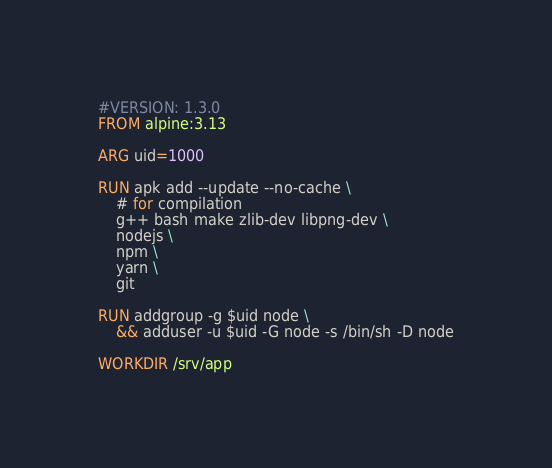Convert code to text. <code><loc_0><loc_0><loc_500><loc_500><_Dockerfile_>#VERSION: 1.3.0
FROM alpine:3.13

ARG uid=1000

RUN apk add --update --no-cache \
    # for compilation
    g++ bash make zlib-dev libpng-dev \
	nodejs \
	npm \
	yarn \
	git

RUN addgroup -g $uid node \
    && adduser -u $uid -G node -s /bin/sh -D node

WORKDIR /srv/app
</code> 